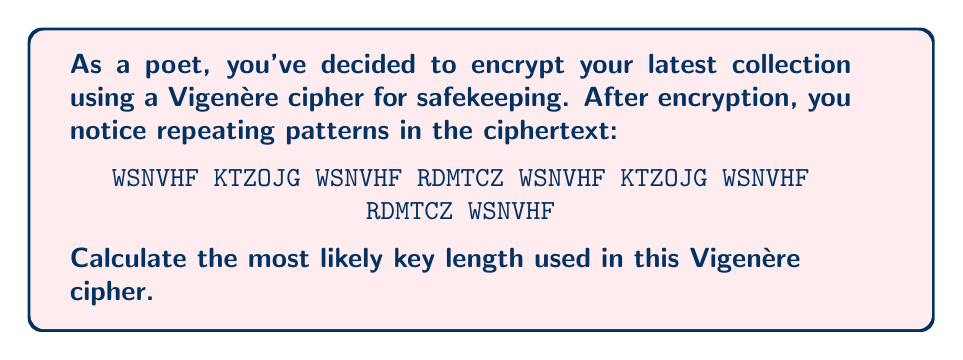What is the answer to this math problem? To determine the key length in a Vigenère cipher from a given ciphertext, we can use the Kasiski examination method. This method involves identifying repeating sequences in the ciphertext and calculating the distances between them. The key length is likely to be a factor of these distances.

Step 1: Identify repeating sequences
We can see that "WSNVHF" repeats multiple times in the ciphertext.

Step 2: Calculate the distances between repeating sequences
The distances between the occurrences of "WSNVHF" are:
- Between 1st and 2nd: 14 characters
- Between 2nd and 3rd: 14 characters
- Between 3rd and 4th: 14 characters
- Between 4th and 5th: 14 characters

Step 3: Determine the factors of the distances
The factors of 14 are: 1, 2, 7, 14

Step 4: Analyze the factors
Since the pattern repeats consistently every 14 characters, the most likely key length is 7. This is because:
1. A key length of 1 or 2 would be too short for a secure Vigenère cipher.
2. A key length of 14 would be unusually long for a typical Vigenère cipher.
3. 7 is the most reasonable factor that could produce this repeating pattern.

Therefore, the most likely key length used in this Vigenère cipher is 7.
Answer: 7 